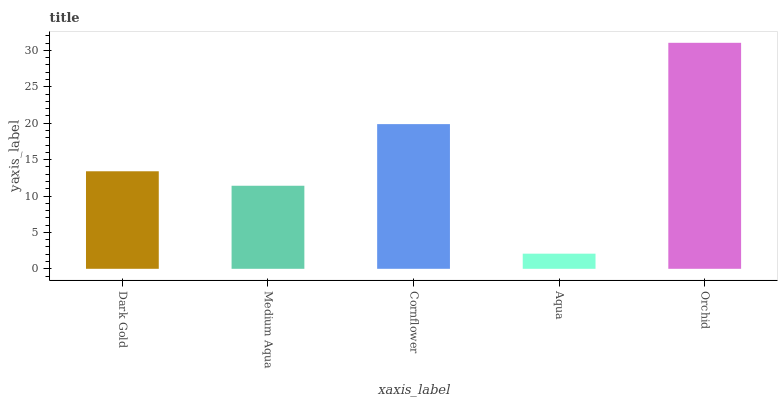Is Medium Aqua the minimum?
Answer yes or no. No. Is Medium Aqua the maximum?
Answer yes or no. No. Is Dark Gold greater than Medium Aqua?
Answer yes or no. Yes. Is Medium Aqua less than Dark Gold?
Answer yes or no. Yes. Is Medium Aqua greater than Dark Gold?
Answer yes or no. No. Is Dark Gold less than Medium Aqua?
Answer yes or no. No. Is Dark Gold the high median?
Answer yes or no. Yes. Is Dark Gold the low median?
Answer yes or no. Yes. Is Orchid the high median?
Answer yes or no. No. Is Aqua the low median?
Answer yes or no. No. 